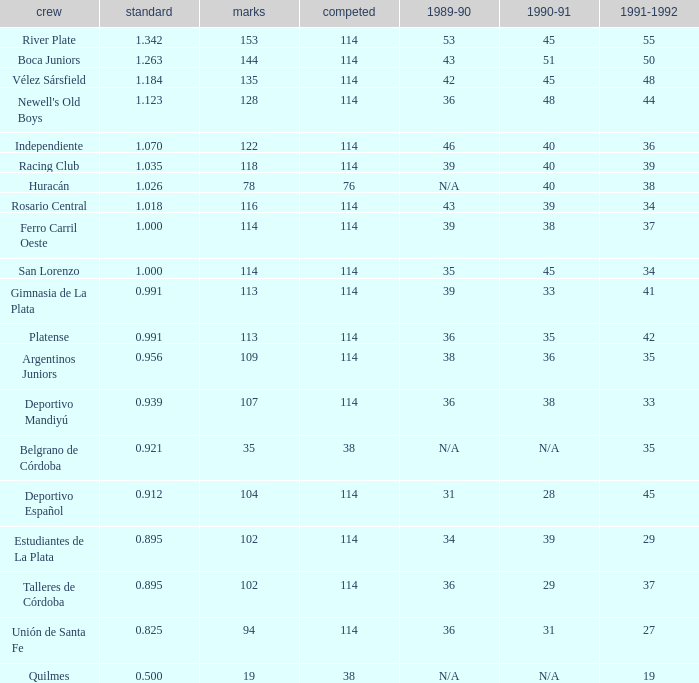How much 1991-1992 has a 1989-90 of 36, and an Average of 0.8250000000000001? 0.0. 